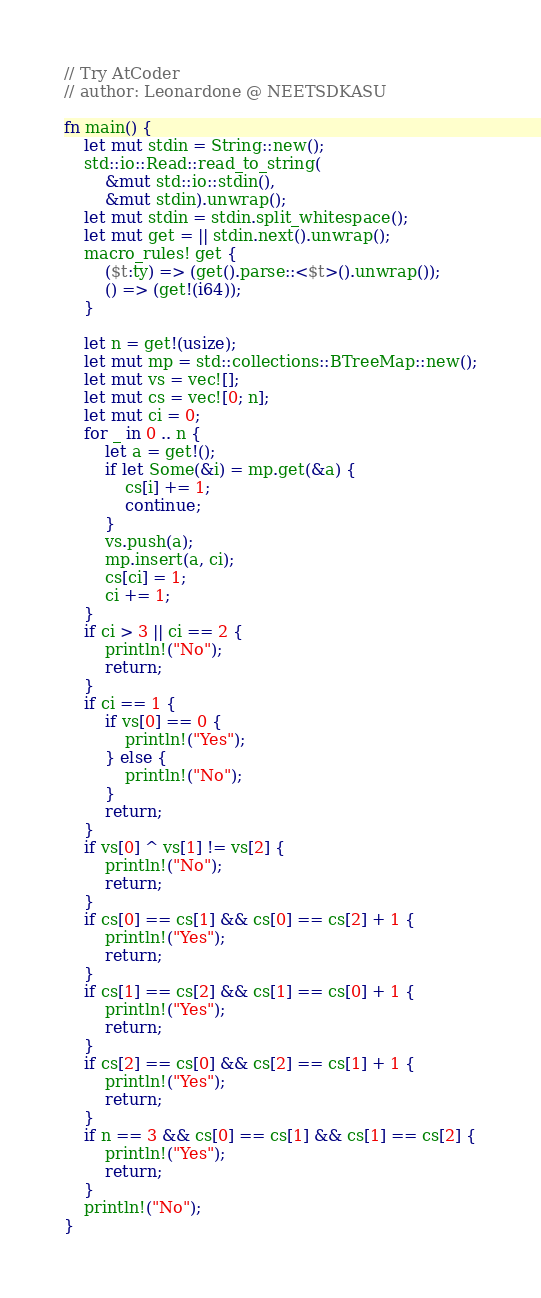<code> <loc_0><loc_0><loc_500><loc_500><_Rust_>// Try AtCoder
// author: Leonardone @ NEETSDKASU

fn main() {
    let mut stdin = String::new();
    std::io::Read::read_to_string(
        &mut std::io::stdin(),
        &mut stdin).unwrap();
    let mut stdin = stdin.split_whitespace();
    let mut get = || stdin.next().unwrap();
    macro_rules! get {
        ($t:ty) => (get().parse::<$t>().unwrap());
        () => (get!(i64));
    }
    
    let n = get!(usize);
    let mut mp = std::collections::BTreeMap::new();
    let mut vs = vec![];
    let mut cs = vec![0; n];
    let mut ci = 0;
    for _ in 0 .. n {
    	let a = get!();
        if let Some(&i) = mp.get(&a) {
            cs[i] += 1;
            continue;
        }
        vs.push(a);
        mp.insert(a, ci);
        cs[ci] = 1;
        ci += 1;
    }
    if ci > 3 || ci == 2 {
        println!("No");
        return;
    }
    if ci == 1 {
        if vs[0] == 0 {
            println!("Yes");
        } else {
            println!("No");
        }
        return;
    }
    if vs[0] ^ vs[1] != vs[2] {
        println!("No");
        return;
    }
    if cs[0] == cs[1] && cs[0] == cs[2] + 1 {
        println!("Yes");
        return;
    }
    if cs[1] == cs[2] && cs[1] == cs[0] + 1 {
        println!("Yes");
        return;
    }
    if cs[2] == cs[0] && cs[2] == cs[1] + 1 {
        println!("Yes");
        return;
    }
    if n == 3 && cs[0] == cs[1] && cs[1] == cs[2] {
        println!("Yes");
        return;
    }
    println!("No");
}</code> 